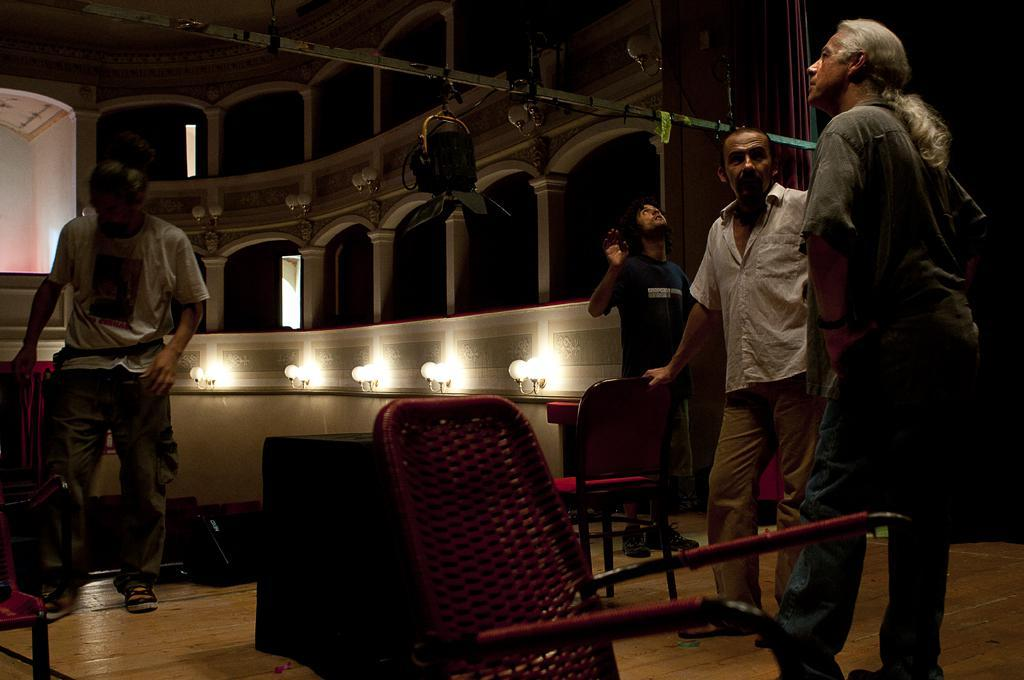How many people are in the image? There are four persons standing in the image. What objects are present for seating purposes? There are chairs in the image. What can be seen providing illumination in the image? There are lights in the image. What architectural elements are visible in the image? There are pillars in the image. What equipment is present for filming purposes? There is a camera crane in the image. Can you describe any other objects in the image? There are some unspecified objects in the image. What type of pencil is being used by the person in the image? There is no pencil present in the image; it is a camera crane, chairs, lights, and pillars that are visible. 